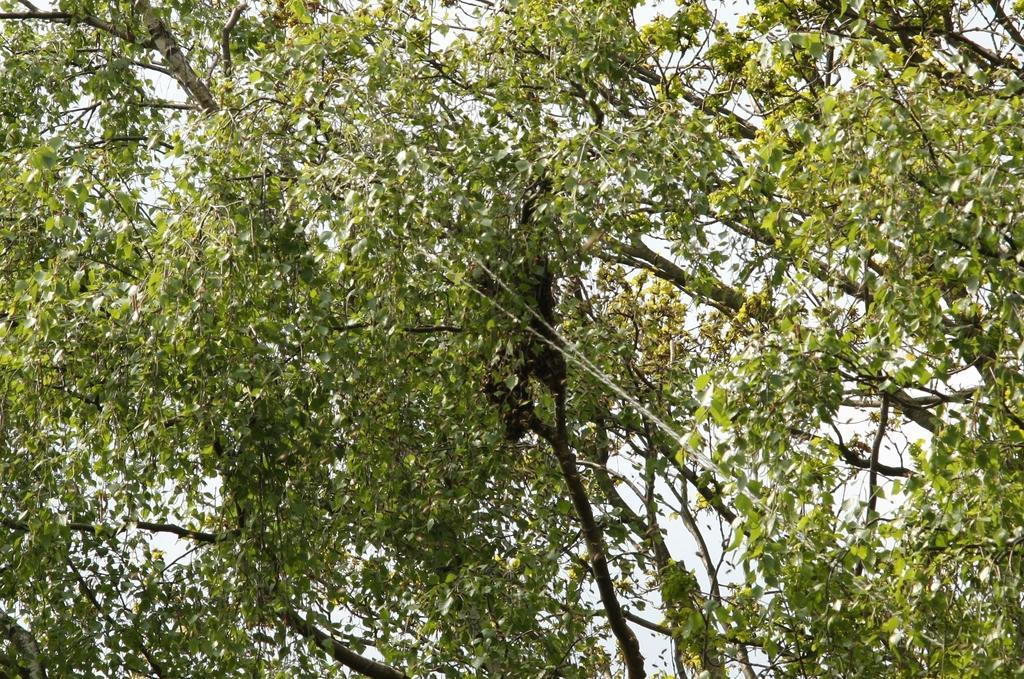Describe this image in one or two sentences. There is a tree which has green leaves on it. 